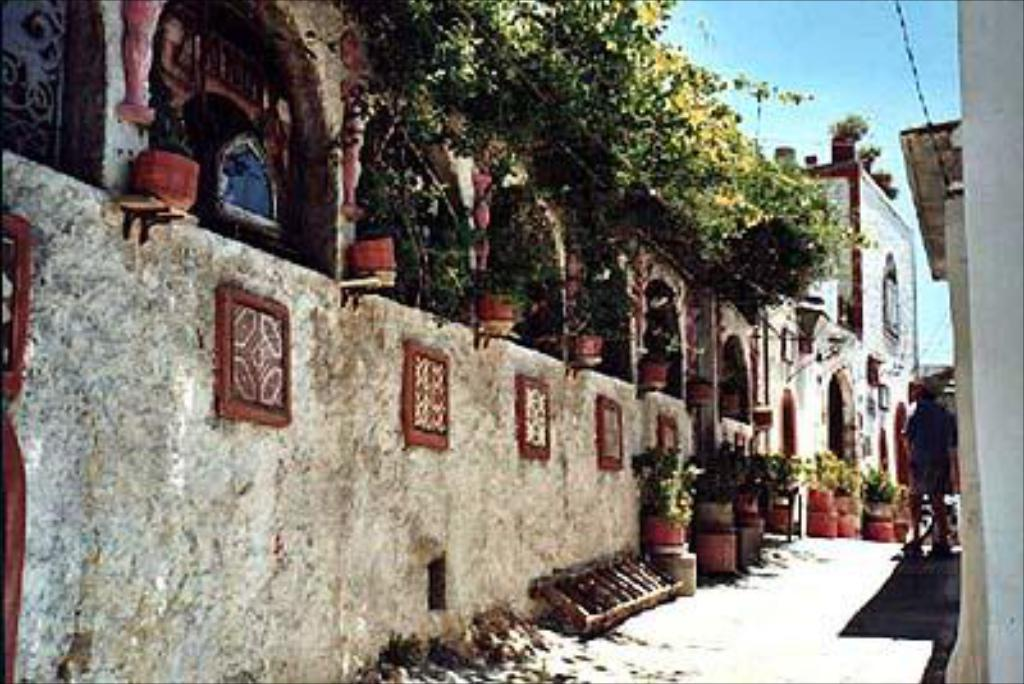What type of plants can be seen in the image? There are house plants in the image. What object is present that can be used for climbing or reaching high places? There is a ladder in the image. What type of structures are visible in the image? There are buildings in the image. What type of vegetation is present in the image? There are trees in the image. What else can be seen in the image besides plants and trees? There are objects in the image. Can you describe the person in the image? There is a person standing on the ground in the image. What is visible in the background of the image? The sky is visible in the background of the image. How many fingers does the person have in the image? The provided facts do not mention the person's fingers, so we cannot determine the number of fingers in the image. Is there a cellar visible in the image? There is no mention of a cellar in the provided facts, so we cannot determine if one is present in the image. 